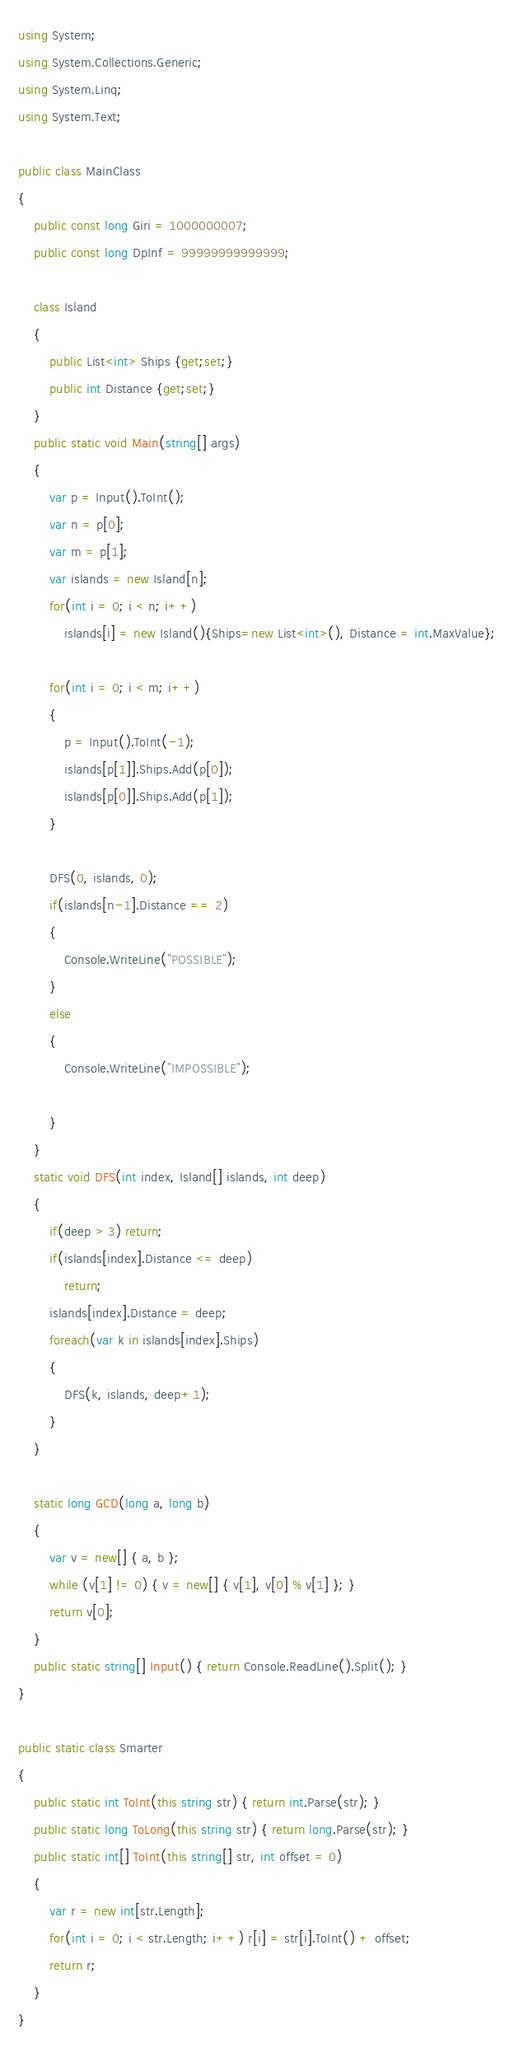Convert code to text. <code><loc_0><loc_0><loc_500><loc_500><_C#_>using System;
using System.Collections.Generic;
using System.Linq;
using System.Text;

public class MainClass
{
	public const long Giri = 1000000007;
	public const long DpInf = 99999999999999;
	
	class Island
	{
		public List<int> Ships {get;set;}
		public int Distance {get;set;}
	}
	public static void Main(string[] args)
	{
		var p = Input().ToInt();
		var n = p[0];
		var m = p[1];
		var islands = new Island[n];
		for(int i = 0; i < n; i++)
			islands[i] = new Island(){Ships=new List<int>(), Distance = int.MaxValue};
			
		for(int i = 0; i < m; i++)
		{
			p = Input().ToInt(-1);
			islands[p[1]].Ships.Add(p[0]);
			islands[p[0]].Ships.Add(p[1]);
		}
		
		DFS(0, islands, 0);
		if(islands[n-1].Distance == 2)
		{
			Console.WriteLine("POSSIBLE");
		}
		else
		{
			Console.WriteLine("IMPOSSIBLE");
		
		}
	}
	static void DFS(int index, Island[] islands, int deep)
	{
		if(deep > 3) return;
		if(islands[index].Distance <= deep)
			return;
		islands[index].Distance = deep;
		foreach(var k in islands[index].Ships)
		{
			DFS(k, islands, deep+1);
		}
	}
	
	static long GCD(long a, long b)
	{
		var v = new[] { a, b };
		while (v[1] != 0) { v = new[] { v[1], v[0] % v[1] }; }
		return v[0];
	}
	public static string[] Input() { return Console.ReadLine().Split(); }
}

public static class Smarter
{
	public static int ToInt(this string str) { return int.Parse(str); }
	public static long ToLong(this string str) { return long.Parse(str); }
	public static int[] ToInt(this string[] str, int offset = 0)
	{
		var r = new int[str.Length];
		for(int i = 0; i < str.Length; i++) r[i] = str[i].ToInt() + offset;
		return r;
	}
}</code> 